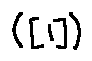<formula> <loc_0><loc_0><loc_500><loc_500>( [ 1 ] )</formula> 